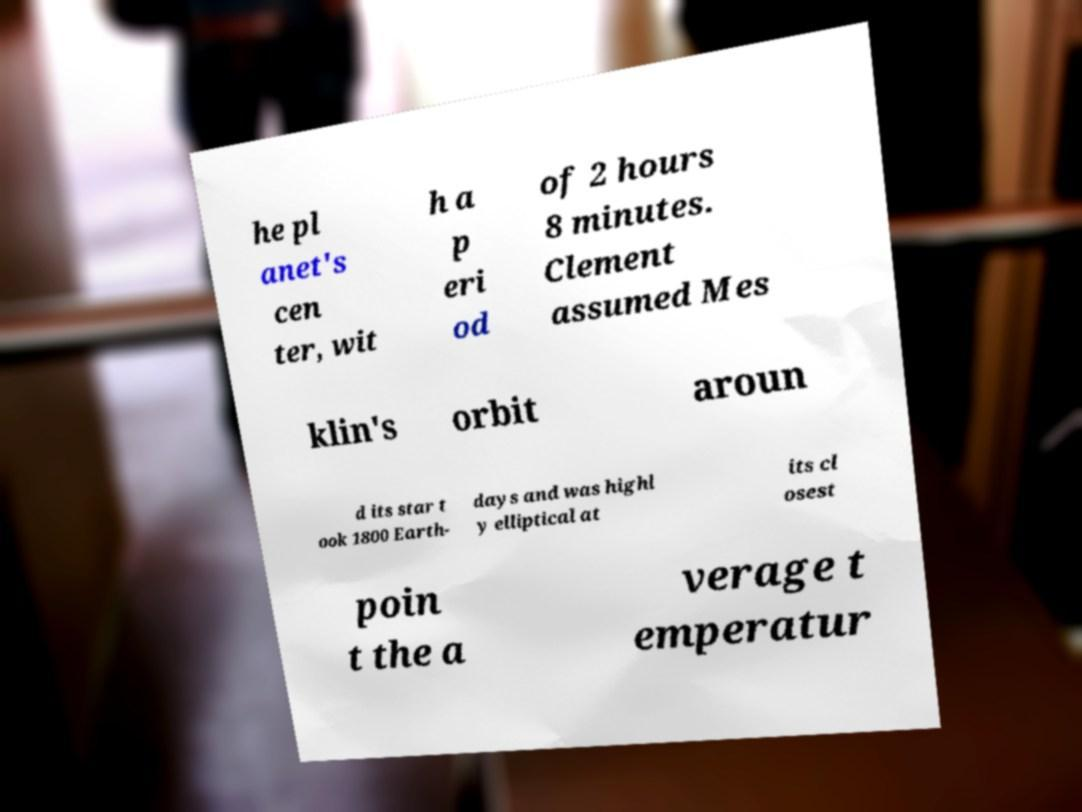What messages or text are displayed in this image? I need them in a readable, typed format. he pl anet's cen ter, wit h a p eri od of 2 hours 8 minutes. Clement assumed Mes klin's orbit aroun d its star t ook 1800 Earth- days and was highl y elliptical at its cl osest poin t the a verage t emperatur 